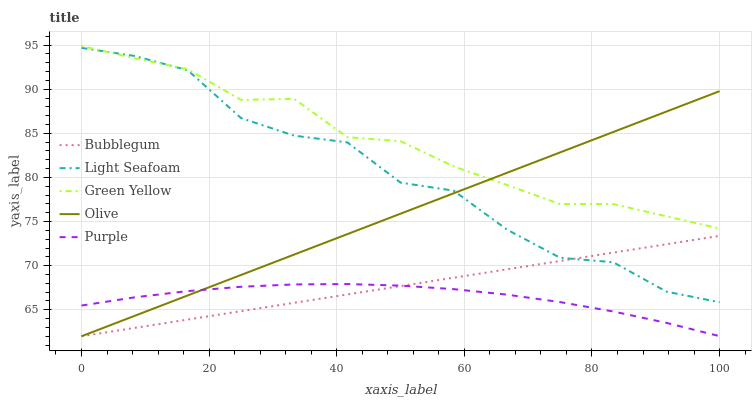Does Purple have the minimum area under the curve?
Answer yes or no. Yes. Does Green Yellow have the maximum area under the curve?
Answer yes or no. Yes. Does Green Yellow have the minimum area under the curve?
Answer yes or no. No. Does Purple have the maximum area under the curve?
Answer yes or no. No. Is Bubblegum the smoothest?
Answer yes or no. Yes. Is Light Seafoam the roughest?
Answer yes or no. Yes. Is Purple the smoothest?
Answer yes or no. No. Is Purple the roughest?
Answer yes or no. No. Does Purple have the lowest value?
Answer yes or no. No. Does Green Yellow have the highest value?
Answer yes or no. Yes. Does Purple have the highest value?
Answer yes or no. No. Is Purple less than Light Seafoam?
Answer yes or no. Yes. Is Green Yellow greater than Purple?
Answer yes or no. Yes. Does Bubblegum intersect Olive?
Answer yes or no. Yes. Is Bubblegum less than Olive?
Answer yes or no. No. Is Bubblegum greater than Olive?
Answer yes or no. No. Does Purple intersect Light Seafoam?
Answer yes or no. No. 